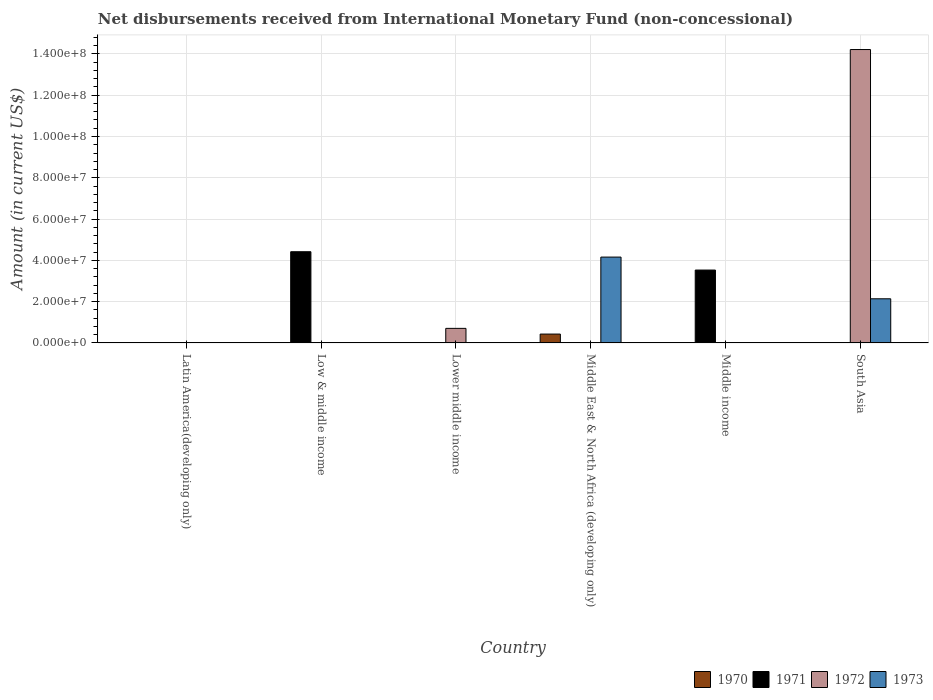How many different coloured bars are there?
Keep it short and to the point. 4. What is the label of the 5th group of bars from the left?
Offer a terse response. Middle income. In how many cases, is the number of bars for a given country not equal to the number of legend labels?
Give a very brief answer. 6. What is the amount of disbursements received from International Monetary Fund in 1970 in Middle income?
Ensure brevity in your answer.  0. Across all countries, what is the maximum amount of disbursements received from International Monetary Fund in 1973?
Your answer should be compact. 4.16e+07. In which country was the amount of disbursements received from International Monetary Fund in 1971 maximum?
Ensure brevity in your answer.  Low & middle income. What is the total amount of disbursements received from International Monetary Fund in 1972 in the graph?
Your response must be concise. 1.49e+08. What is the difference between the amount of disbursements received from International Monetary Fund in 1973 in Middle East & North Africa (developing only) and that in South Asia?
Make the answer very short. 2.02e+07. What is the difference between the amount of disbursements received from International Monetary Fund in 1970 in Middle income and the amount of disbursements received from International Monetary Fund in 1972 in Lower middle income?
Make the answer very short. -7.06e+06. What is the average amount of disbursements received from International Monetary Fund in 1971 per country?
Give a very brief answer. 1.32e+07. What is the difference between the amount of disbursements received from International Monetary Fund of/in 1970 and amount of disbursements received from International Monetary Fund of/in 1973 in Middle East & North Africa (developing only)?
Your answer should be very brief. -3.73e+07. What is the ratio of the amount of disbursements received from International Monetary Fund in 1971 in Low & middle income to that in Middle income?
Keep it short and to the point. 1.25. What is the difference between the highest and the lowest amount of disbursements received from International Monetary Fund in 1970?
Your response must be concise. 4.30e+06. How many bars are there?
Your answer should be very brief. 7. How many countries are there in the graph?
Provide a short and direct response. 6. Does the graph contain any zero values?
Ensure brevity in your answer.  Yes. Where does the legend appear in the graph?
Your response must be concise. Bottom right. How are the legend labels stacked?
Keep it short and to the point. Horizontal. What is the title of the graph?
Provide a succinct answer. Net disbursements received from International Monetary Fund (non-concessional). Does "1971" appear as one of the legend labels in the graph?
Ensure brevity in your answer.  Yes. What is the label or title of the X-axis?
Your answer should be very brief. Country. What is the label or title of the Y-axis?
Offer a terse response. Amount (in current US$). What is the Amount (in current US$) in 1970 in Latin America(developing only)?
Provide a short and direct response. 0. What is the Amount (in current US$) of 1971 in Latin America(developing only)?
Give a very brief answer. 0. What is the Amount (in current US$) of 1973 in Latin America(developing only)?
Offer a terse response. 0. What is the Amount (in current US$) in 1970 in Low & middle income?
Provide a succinct answer. 0. What is the Amount (in current US$) of 1971 in Low & middle income?
Offer a very short reply. 4.42e+07. What is the Amount (in current US$) in 1972 in Low & middle income?
Your answer should be very brief. 0. What is the Amount (in current US$) in 1970 in Lower middle income?
Your answer should be very brief. 0. What is the Amount (in current US$) of 1971 in Lower middle income?
Offer a very short reply. 0. What is the Amount (in current US$) of 1972 in Lower middle income?
Give a very brief answer. 7.06e+06. What is the Amount (in current US$) of 1970 in Middle East & North Africa (developing only)?
Your answer should be very brief. 4.30e+06. What is the Amount (in current US$) in 1971 in Middle East & North Africa (developing only)?
Keep it short and to the point. 0. What is the Amount (in current US$) in 1972 in Middle East & North Africa (developing only)?
Offer a terse response. 0. What is the Amount (in current US$) of 1973 in Middle East & North Africa (developing only)?
Keep it short and to the point. 4.16e+07. What is the Amount (in current US$) of 1970 in Middle income?
Your answer should be compact. 0. What is the Amount (in current US$) of 1971 in Middle income?
Offer a very short reply. 3.53e+07. What is the Amount (in current US$) in 1973 in Middle income?
Ensure brevity in your answer.  0. What is the Amount (in current US$) of 1972 in South Asia?
Provide a succinct answer. 1.42e+08. What is the Amount (in current US$) of 1973 in South Asia?
Keep it short and to the point. 2.14e+07. Across all countries, what is the maximum Amount (in current US$) of 1970?
Your answer should be very brief. 4.30e+06. Across all countries, what is the maximum Amount (in current US$) in 1971?
Your answer should be very brief. 4.42e+07. Across all countries, what is the maximum Amount (in current US$) of 1972?
Provide a succinct answer. 1.42e+08. Across all countries, what is the maximum Amount (in current US$) of 1973?
Give a very brief answer. 4.16e+07. Across all countries, what is the minimum Amount (in current US$) of 1972?
Provide a succinct answer. 0. Across all countries, what is the minimum Amount (in current US$) of 1973?
Offer a terse response. 0. What is the total Amount (in current US$) of 1970 in the graph?
Offer a terse response. 4.30e+06. What is the total Amount (in current US$) in 1971 in the graph?
Your answer should be compact. 7.95e+07. What is the total Amount (in current US$) of 1972 in the graph?
Your answer should be compact. 1.49e+08. What is the total Amount (in current US$) of 1973 in the graph?
Offer a very short reply. 6.30e+07. What is the difference between the Amount (in current US$) of 1971 in Low & middle income and that in Middle income?
Provide a succinct answer. 8.88e+06. What is the difference between the Amount (in current US$) of 1972 in Lower middle income and that in South Asia?
Your response must be concise. -1.35e+08. What is the difference between the Amount (in current US$) of 1973 in Middle East & North Africa (developing only) and that in South Asia?
Provide a short and direct response. 2.02e+07. What is the difference between the Amount (in current US$) of 1971 in Low & middle income and the Amount (in current US$) of 1972 in Lower middle income?
Offer a terse response. 3.71e+07. What is the difference between the Amount (in current US$) in 1971 in Low & middle income and the Amount (in current US$) in 1973 in Middle East & North Africa (developing only)?
Your response must be concise. 2.60e+06. What is the difference between the Amount (in current US$) of 1971 in Low & middle income and the Amount (in current US$) of 1972 in South Asia?
Your response must be concise. -9.79e+07. What is the difference between the Amount (in current US$) of 1971 in Low & middle income and the Amount (in current US$) of 1973 in South Asia?
Make the answer very short. 2.28e+07. What is the difference between the Amount (in current US$) of 1972 in Lower middle income and the Amount (in current US$) of 1973 in Middle East & North Africa (developing only)?
Ensure brevity in your answer.  -3.45e+07. What is the difference between the Amount (in current US$) in 1972 in Lower middle income and the Amount (in current US$) in 1973 in South Asia?
Provide a short and direct response. -1.43e+07. What is the difference between the Amount (in current US$) of 1970 in Middle East & North Africa (developing only) and the Amount (in current US$) of 1971 in Middle income?
Provide a short and direct response. -3.10e+07. What is the difference between the Amount (in current US$) of 1970 in Middle East & North Africa (developing only) and the Amount (in current US$) of 1972 in South Asia?
Provide a succinct answer. -1.38e+08. What is the difference between the Amount (in current US$) of 1970 in Middle East & North Africa (developing only) and the Amount (in current US$) of 1973 in South Asia?
Offer a very short reply. -1.71e+07. What is the difference between the Amount (in current US$) in 1971 in Middle income and the Amount (in current US$) in 1972 in South Asia?
Ensure brevity in your answer.  -1.07e+08. What is the difference between the Amount (in current US$) in 1971 in Middle income and the Amount (in current US$) in 1973 in South Asia?
Your response must be concise. 1.39e+07. What is the average Amount (in current US$) of 1970 per country?
Make the answer very short. 7.17e+05. What is the average Amount (in current US$) in 1971 per country?
Provide a succinct answer. 1.32e+07. What is the average Amount (in current US$) of 1972 per country?
Ensure brevity in your answer.  2.49e+07. What is the average Amount (in current US$) in 1973 per country?
Provide a short and direct response. 1.05e+07. What is the difference between the Amount (in current US$) of 1970 and Amount (in current US$) of 1973 in Middle East & North Africa (developing only)?
Offer a very short reply. -3.73e+07. What is the difference between the Amount (in current US$) of 1972 and Amount (in current US$) of 1973 in South Asia?
Offer a very short reply. 1.21e+08. What is the ratio of the Amount (in current US$) in 1971 in Low & middle income to that in Middle income?
Give a very brief answer. 1.25. What is the ratio of the Amount (in current US$) in 1972 in Lower middle income to that in South Asia?
Provide a succinct answer. 0.05. What is the ratio of the Amount (in current US$) in 1973 in Middle East & North Africa (developing only) to that in South Asia?
Your response must be concise. 1.94. What is the difference between the highest and the lowest Amount (in current US$) of 1970?
Provide a succinct answer. 4.30e+06. What is the difference between the highest and the lowest Amount (in current US$) in 1971?
Give a very brief answer. 4.42e+07. What is the difference between the highest and the lowest Amount (in current US$) in 1972?
Provide a succinct answer. 1.42e+08. What is the difference between the highest and the lowest Amount (in current US$) in 1973?
Give a very brief answer. 4.16e+07. 